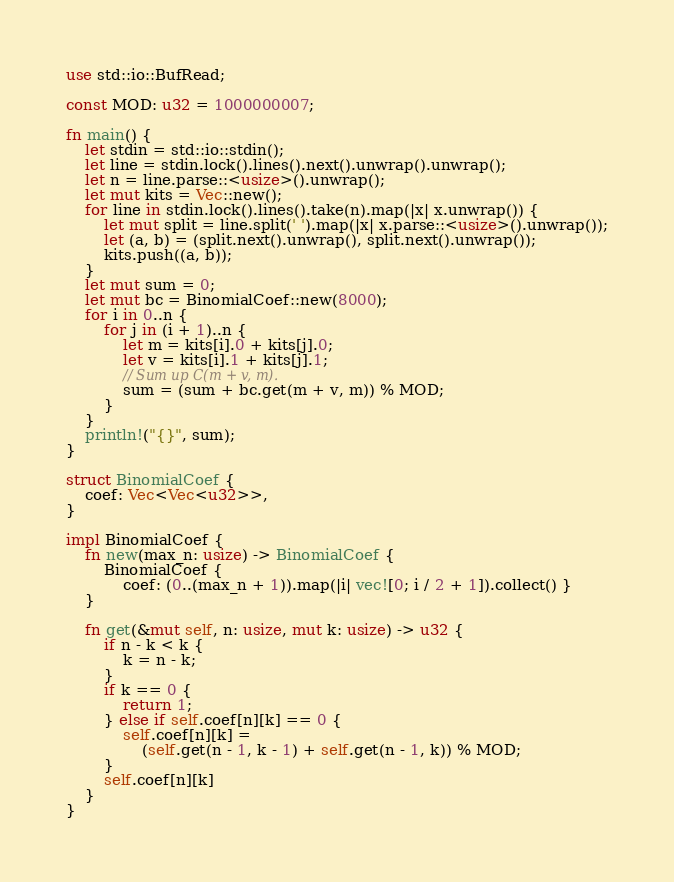Convert code to text. <code><loc_0><loc_0><loc_500><loc_500><_Rust_>use std::io::BufRead;

const MOD: u32 = 1000000007;

fn main() {
    let stdin = std::io::stdin();
    let line = stdin.lock().lines().next().unwrap().unwrap();
    let n = line.parse::<usize>().unwrap();
    let mut kits = Vec::new();
    for line in stdin.lock().lines().take(n).map(|x| x.unwrap()) {
        let mut split = line.split(' ').map(|x| x.parse::<usize>().unwrap());
        let (a, b) = (split.next().unwrap(), split.next().unwrap());
        kits.push((a, b));
    }
    let mut sum = 0;
    let mut bc = BinomialCoef::new(8000);
    for i in 0..n {
        for j in (i + 1)..n {
            let m = kits[i].0 + kits[j].0;
            let v = kits[i].1 + kits[j].1;
            // Sum up C(m + v, m).
            sum = (sum + bc.get(m + v, m)) % MOD;
        }
    }
    println!("{}", sum);
}

struct BinomialCoef {
    coef: Vec<Vec<u32>>,
}

impl BinomialCoef {
    fn new(max_n: usize) -> BinomialCoef {
        BinomialCoef {
            coef: (0..(max_n + 1)).map(|i| vec![0; i / 2 + 1]).collect() }
    }

    fn get(&mut self, n: usize, mut k: usize) -> u32 {
        if n - k < k {
            k = n - k;
        }
        if k == 0 {
            return 1;
        } else if self.coef[n][k] == 0 {
            self.coef[n][k] =
                (self.get(n - 1, k - 1) + self.get(n - 1, k)) % MOD;
        }
        self.coef[n][k]
    }
}
</code> 